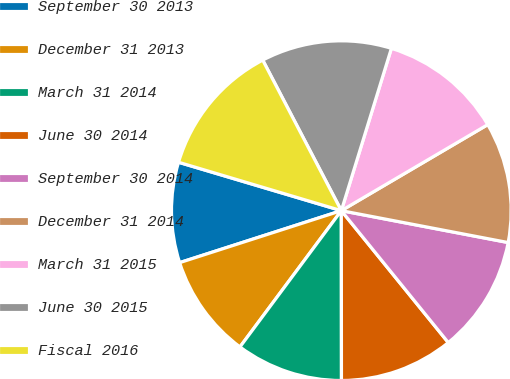<chart> <loc_0><loc_0><loc_500><loc_500><pie_chart><fcel>September 30 2013<fcel>December 31 2013<fcel>March 31 2014<fcel>June 30 2014<fcel>September 30 2014<fcel>December 31 2014<fcel>March 31 2015<fcel>June 30 2015<fcel>Fiscal 2016<nl><fcel>9.55%<fcel>9.87%<fcel>10.19%<fcel>10.83%<fcel>11.15%<fcel>11.46%<fcel>11.78%<fcel>12.42%<fcel>12.74%<nl></chart> 